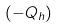<formula> <loc_0><loc_0><loc_500><loc_500>( - Q _ { h } )</formula> 